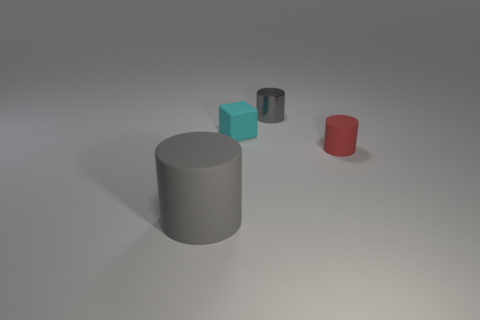Subtract all small red rubber cylinders. How many cylinders are left? 2 Add 4 big objects. How many objects exist? 8 Subtract all cubes. How many objects are left? 3 Add 1 tiny red things. How many tiny red things are left? 2 Add 1 big matte things. How many big matte things exist? 2 Subtract all gray cylinders. How many cylinders are left? 1 Subtract 0 purple cylinders. How many objects are left? 4 Subtract 1 cylinders. How many cylinders are left? 2 Subtract all purple cylinders. Subtract all gray cubes. How many cylinders are left? 3 Subtract all brown blocks. How many red cylinders are left? 1 